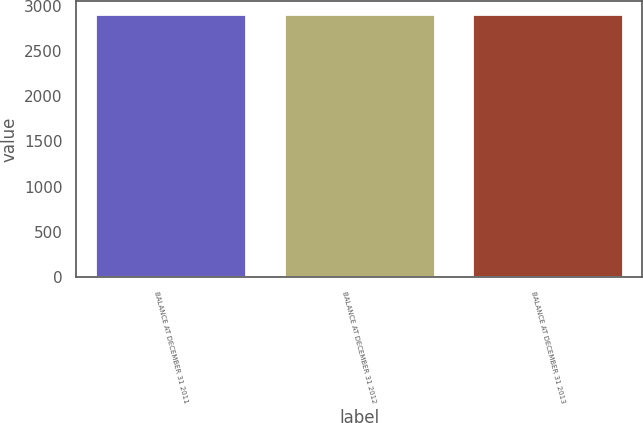<chart> <loc_0><loc_0><loc_500><loc_500><bar_chart><fcel>BALANCE AT DECEMBER 31 2011<fcel>BALANCE AT DECEMBER 31 2012<fcel>BALANCE AT DECEMBER 31 2013<nl><fcel>2905<fcel>2905.1<fcel>2905.2<nl></chart> 